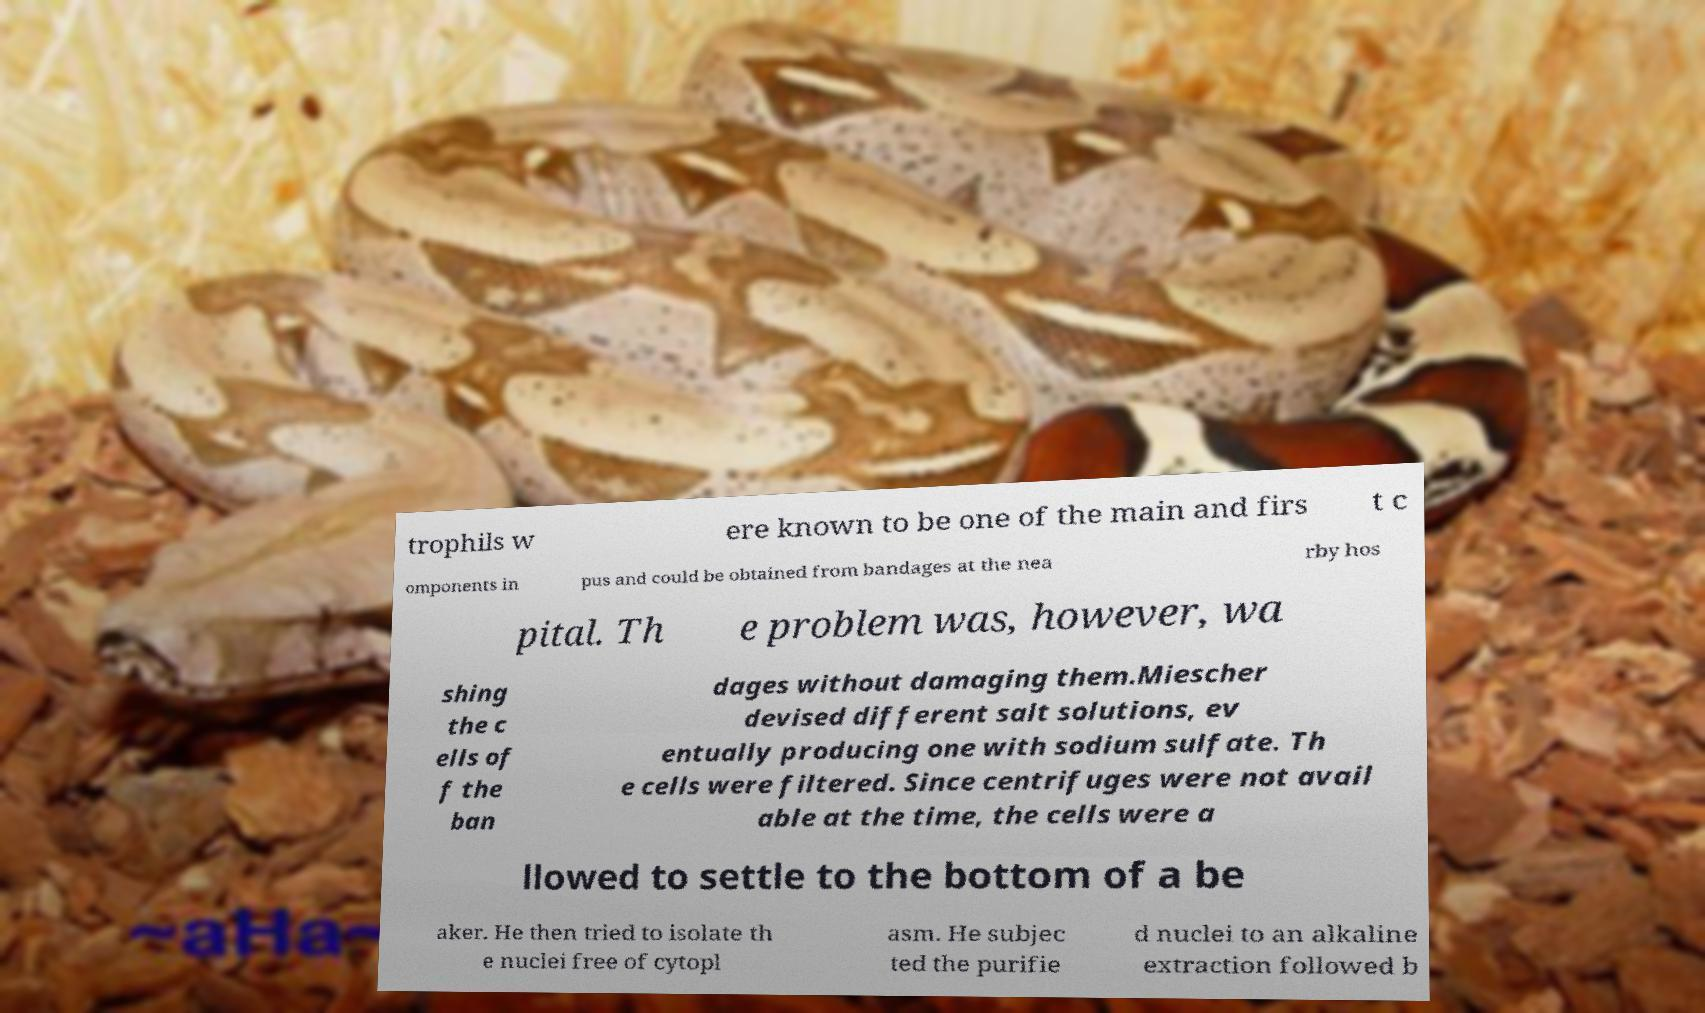There's text embedded in this image that I need extracted. Can you transcribe it verbatim? trophils w ere known to be one of the main and firs t c omponents in pus and could be obtained from bandages at the nea rby hos pital. Th e problem was, however, wa shing the c ells of f the ban dages without damaging them.Miescher devised different salt solutions, ev entually producing one with sodium sulfate. Th e cells were filtered. Since centrifuges were not avail able at the time, the cells were a llowed to settle to the bottom of a be aker. He then tried to isolate th e nuclei free of cytopl asm. He subjec ted the purifie d nuclei to an alkaline extraction followed b 